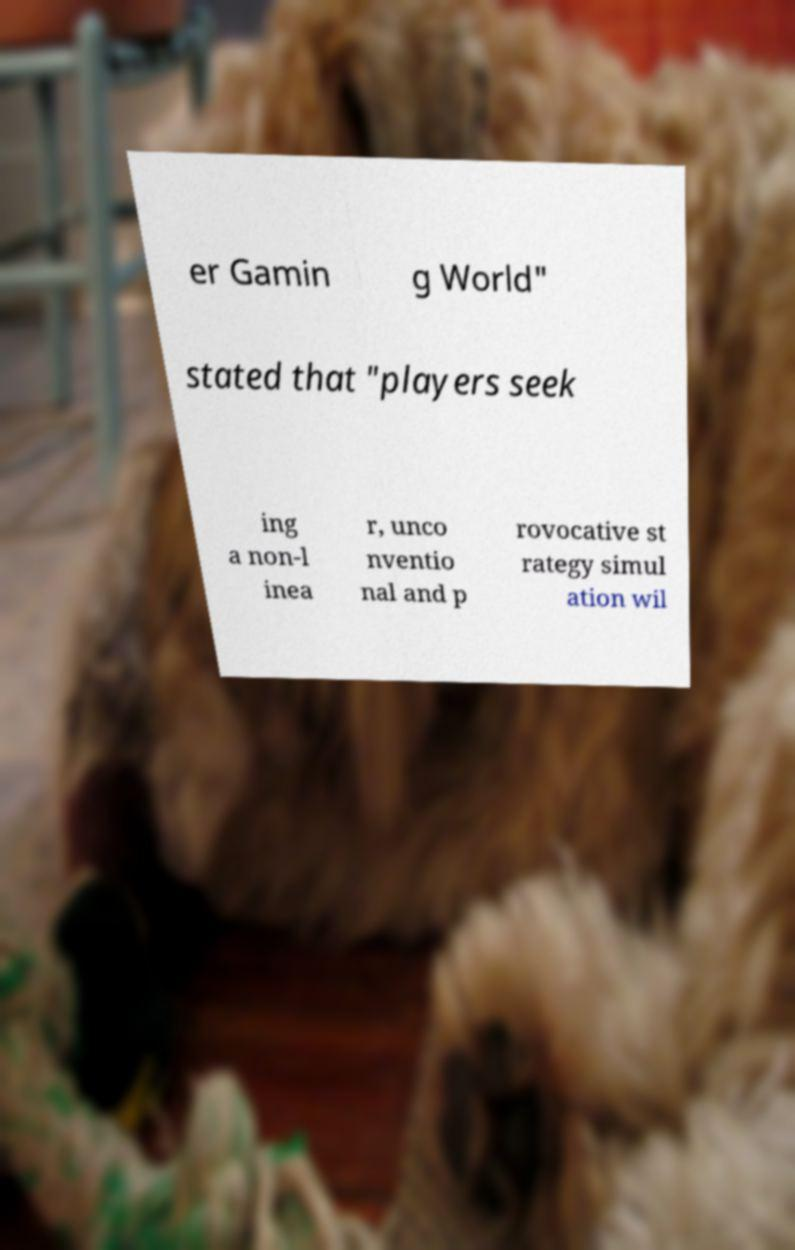Can you read and provide the text displayed in the image?This photo seems to have some interesting text. Can you extract and type it out for me? er Gamin g World" stated that "players seek ing a non-l inea r, unco nventio nal and p rovocative st rategy simul ation wil 